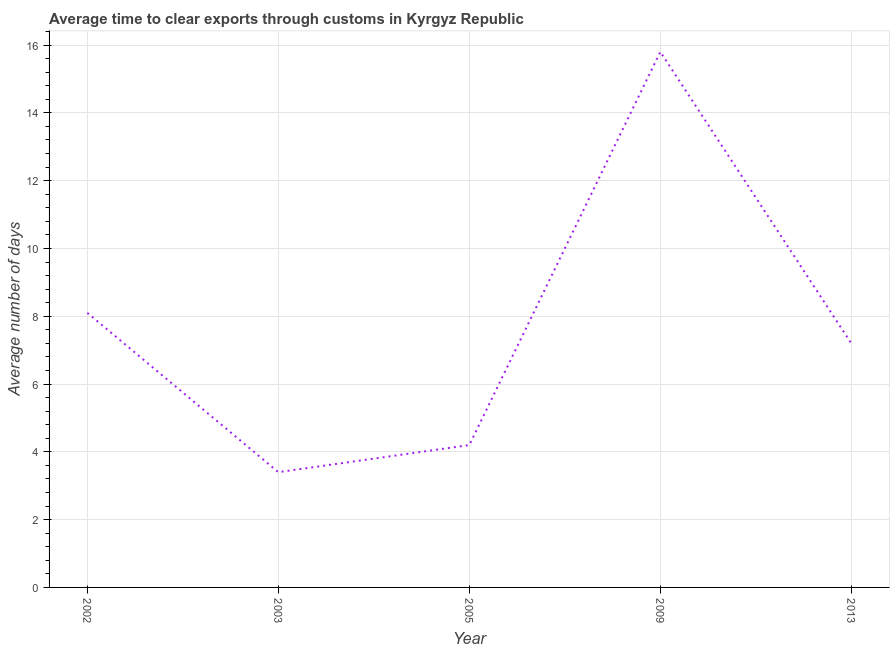What is the time to clear exports through customs in 2013?
Keep it short and to the point. 7.2. Across all years, what is the minimum time to clear exports through customs?
Ensure brevity in your answer.  3.4. In which year was the time to clear exports through customs maximum?
Provide a short and direct response. 2009. What is the sum of the time to clear exports through customs?
Provide a succinct answer. 38.7. What is the difference between the time to clear exports through customs in 2002 and 2013?
Offer a terse response. 0.9. What is the average time to clear exports through customs per year?
Your answer should be compact. 7.74. What is the median time to clear exports through customs?
Your answer should be very brief. 7.2. What is the ratio of the time to clear exports through customs in 2003 to that in 2005?
Give a very brief answer. 0.81. Is the time to clear exports through customs in 2002 less than that in 2013?
Your answer should be very brief. No. What is the difference between the highest and the second highest time to clear exports through customs?
Ensure brevity in your answer.  7.7. Is the sum of the time to clear exports through customs in 2002 and 2005 greater than the maximum time to clear exports through customs across all years?
Give a very brief answer. No. Does the time to clear exports through customs monotonically increase over the years?
Your answer should be very brief. No. How many lines are there?
Your answer should be very brief. 1. How many years are there in the graph?
Ensure brevity in your answer.  5. What is the difference between two consecutive major ticks on the Y-axis?
Offer a terse response. 2. Does the graph contain grids?
Ensure brevity in your answer.  Yes. What is the title of the graph?
Provide a short and direct response. Average time to clear exports through customs in Kyrgyz Republic. What is the label or title of the Y-axis?
Provide a succinct answer. Average number of days. What is the Average number of days of 2009?
Offer a terse response. 15.8. What is the Average number of days of 2013?
Offer a terse response. 7.2. What is the difference between the Average number of days in 2002 and 2003?
Give a very brief answer. 4.7. What is the difference between the Average number of days in 2002 and 2005?
Offer a very short reply. 3.9. What is the difference between the Average number of days in 2002 and 2009?
Offer a very short reply. -7.7. What is the difference between the Average number of days in 2002 and 2013?
Offer a very short reply. 0.9. What is the difference between the Average number of days in 2003 and 2013?
Offer a terse response. -3.8. What is the difference between the Average number of days in 2005 and 2013?
Provide a short and direct response. -3. What is the ratio of the Average number of days in 2002 to that in 2003?
Keep it short and to the point. 2.38. What is the ratio of the Average number of days in 2002 to that in 2005?
Offer a terse response. 1.93. What is the ratio of the Average number of days in 2002 to that in 2009?
Ensure brevity in your answer.  0.51. What is the ratio of the Average number of days in 2002 to that in 2013?
Keep it short and to the point. 1.12. What is the ratio of the Average number of days in 2003 to that in 2005?
Keep it short and to the point. 0.81. What is the ratio of the Average number of days in 2003 to that in 2009?
Offer a very short reply. 0.21. What is the ratio of the Average number of days in 2003 to that in 2013?
Offer a terse response. 0.47. What is the ratio of the Average number of days in 2005 to that in 2009?
Offer a terse response. 0.27. What is the ratio of the Average number of days in 2005 to that in 2013?
Your answer should be compact. 0.58. What is the ratio of the Average number of days in 2009 to that in 2013?
Provide a succinct answer. 2.19. 